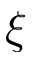Convert formula to latex. <formula><loc_0><loc_0><loc_500><loc_500>\xi</formula> 